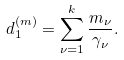<formula> <loc_0><loc_0><loc_500><loc_500>d _ { 1 } ^ { ( m ) } = \sum _ { \nu = 1 } ^ { k } \frac { m _ { \nu } } { \gamma _ { \nu } } .</formula> 